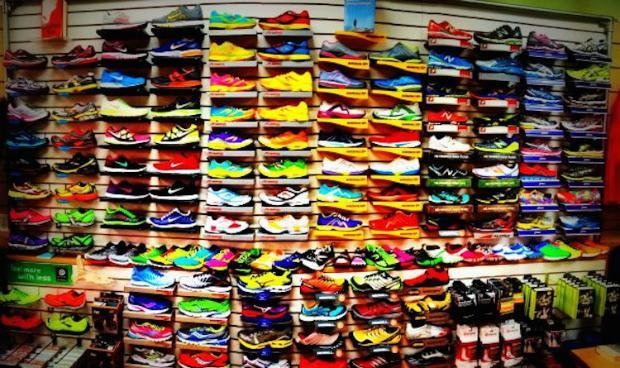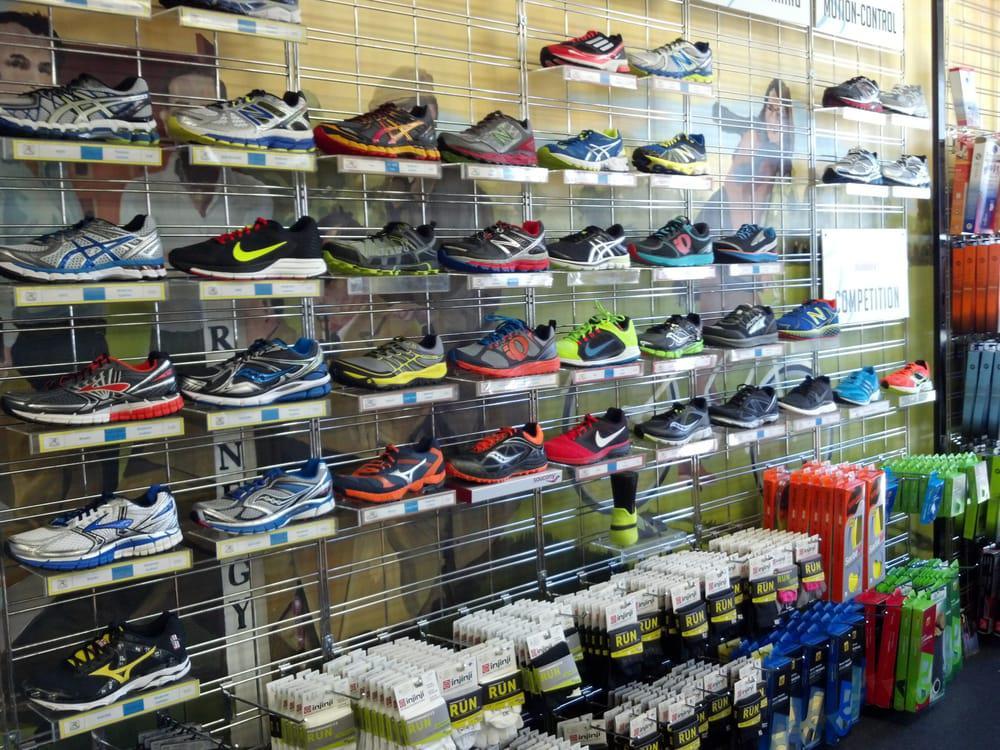The first image is the image on the left, the second image is the image on the right. Considering the images on both sides, is "One image shows different sneakers which are not displayed in rows on shelves." valid? Answer yes or no. No. The first image is the image on the left, the second image is the image on the right. Given the left and right images, does the statement "The shoes in one of the images are not sitting on the store racks." hold true? Answer yes or no. No. The first image is the image on the left, the second image is the image on the right. Examine the images to the left and right. Is the description "One image has less than sixteen shoes present." accurate? Answer yes or no. No. 